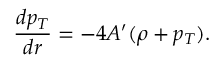Convert formula to latex. <formula><loc_0><loc_0><loc_500><loc_500>{ \frac { d p _ { T } } { d r } } = - 4 A ^ { \prime } ( \rho + p _ { T } ) .</formula> 